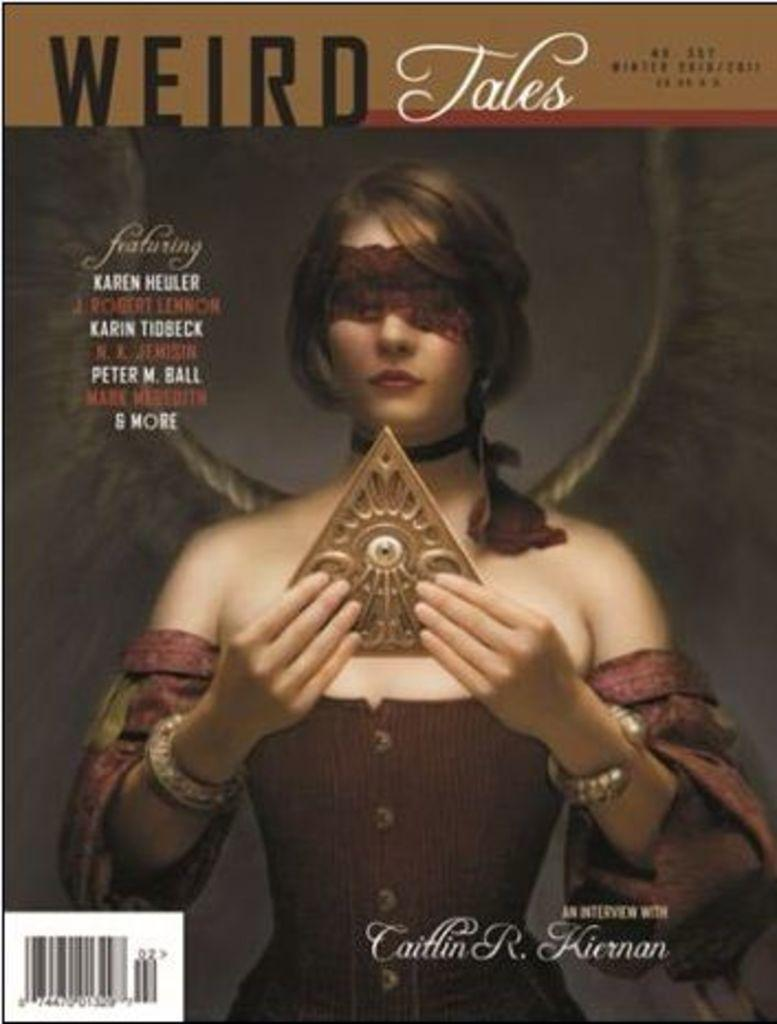<image>
Describe the image concisely. A magazine cover entitled Weird Tales An Interview with Caitlin R. Kiernan 